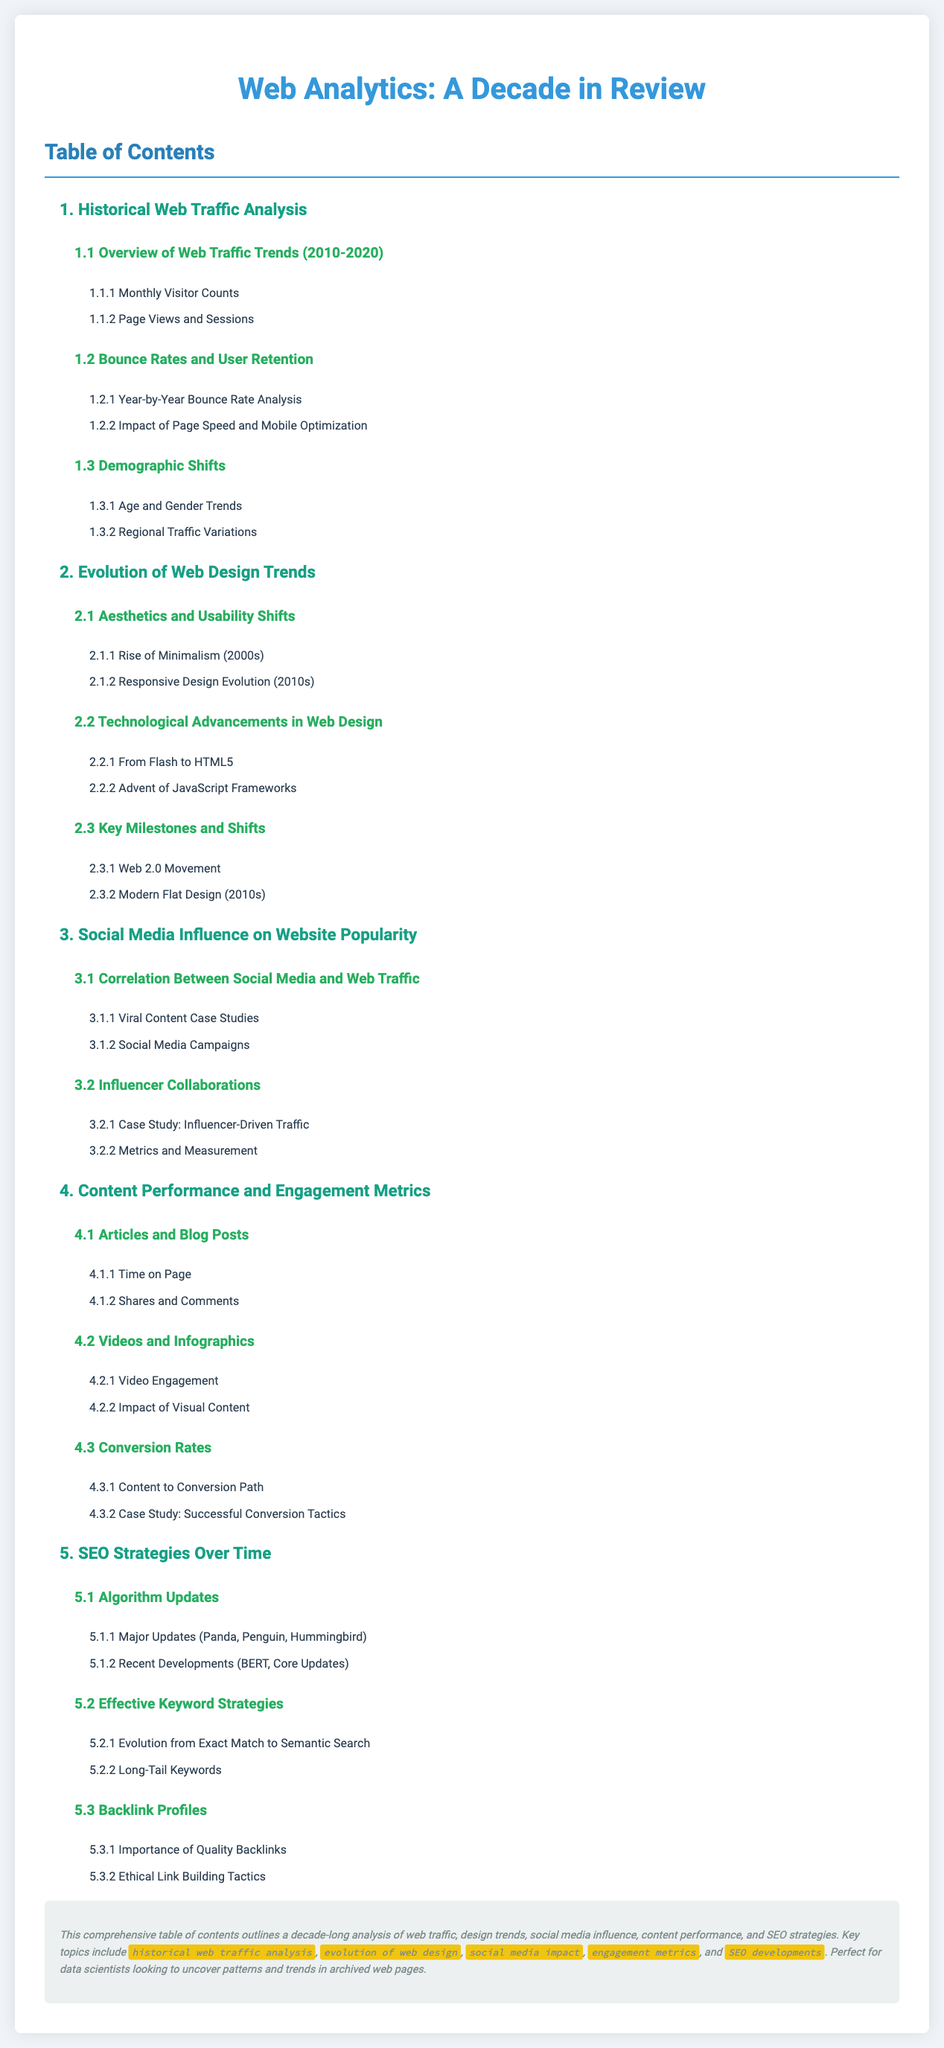What is the title of the document? The title is prominently displayed at the top of the document.
Answer: Web Analytics: A Decade in Review What is the first section of the Table of Contents? The first section is noted at the beginning of the list.
Answer: Historical Web Traffic Analysis Which decade does the historical web traffic analysis cover? The decade is specified in the overview of the first section.
Answer: 2010-2020 What are two types of content analyzed for performance? The types of content are listed in the fourth section of the Table of Contents.
Answer: Articles and Videos Name one technological advancement in web design discussed? The advancements are listed under the second section title.
Answer: HTML5 How many subsections does the SEO Strategies Over Time section have? The number is determined by counting the nested lists under the fifth section.
Answer: Three What is one key aspect of the social media influence section? It describes a focus on specific case studies or collaboration types.
Answer: Influencer Collaborations What color is used for the section headers? The color is generally used for headings throughout the document.
Answer: Blue 